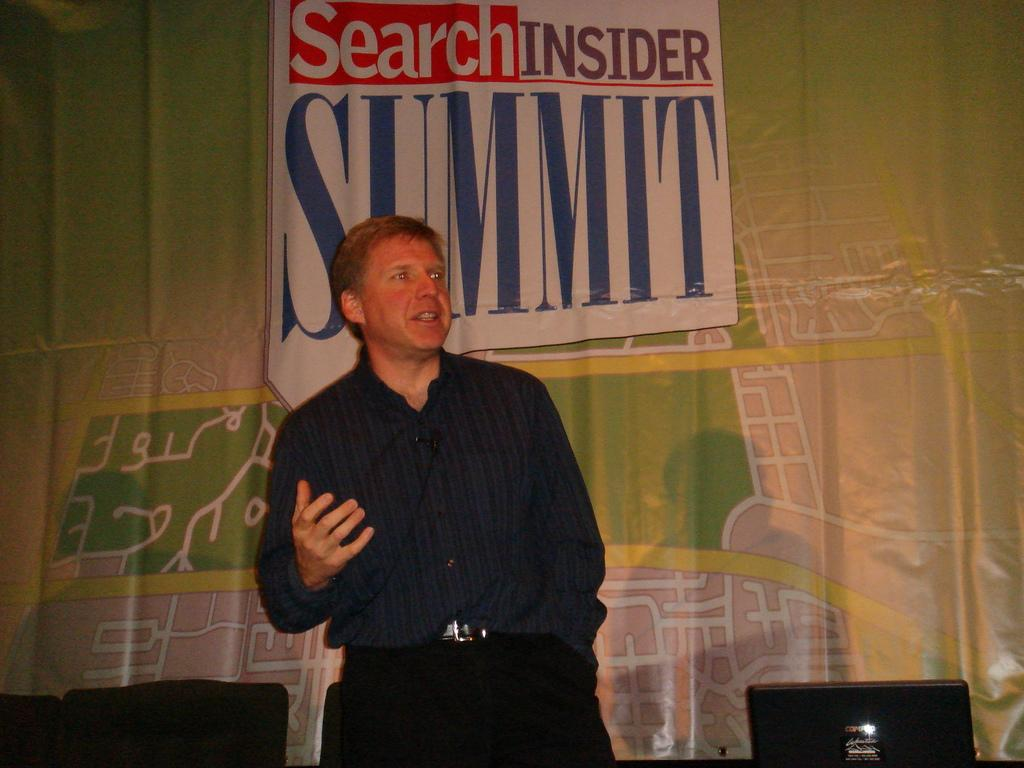What is located in the foreground of the image? There is a person and a laptop in the foreground of the image. What else can be seen in the foreground of the image? There are chairs in the foreground of the image. What is visible in the background of the image? There is a wall and a poster in the background of the image. Where was the image taken? The image was taken in a hall. Can you tell me what type of oven is being used by the person in the image? There is no oven present in the image; it features a person with a laptop and chairs in a hall. How many people are kissing in the image? There are no people kissing in the image; it only shows a person with a laptop and chairs in a hall. 